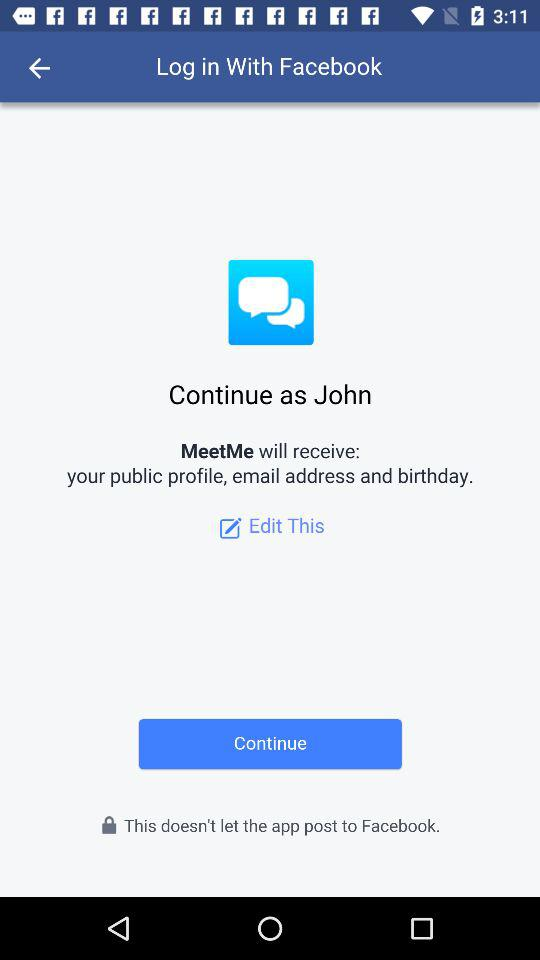What application is asking for permission? The application "MeetMe" is asking for permission. 